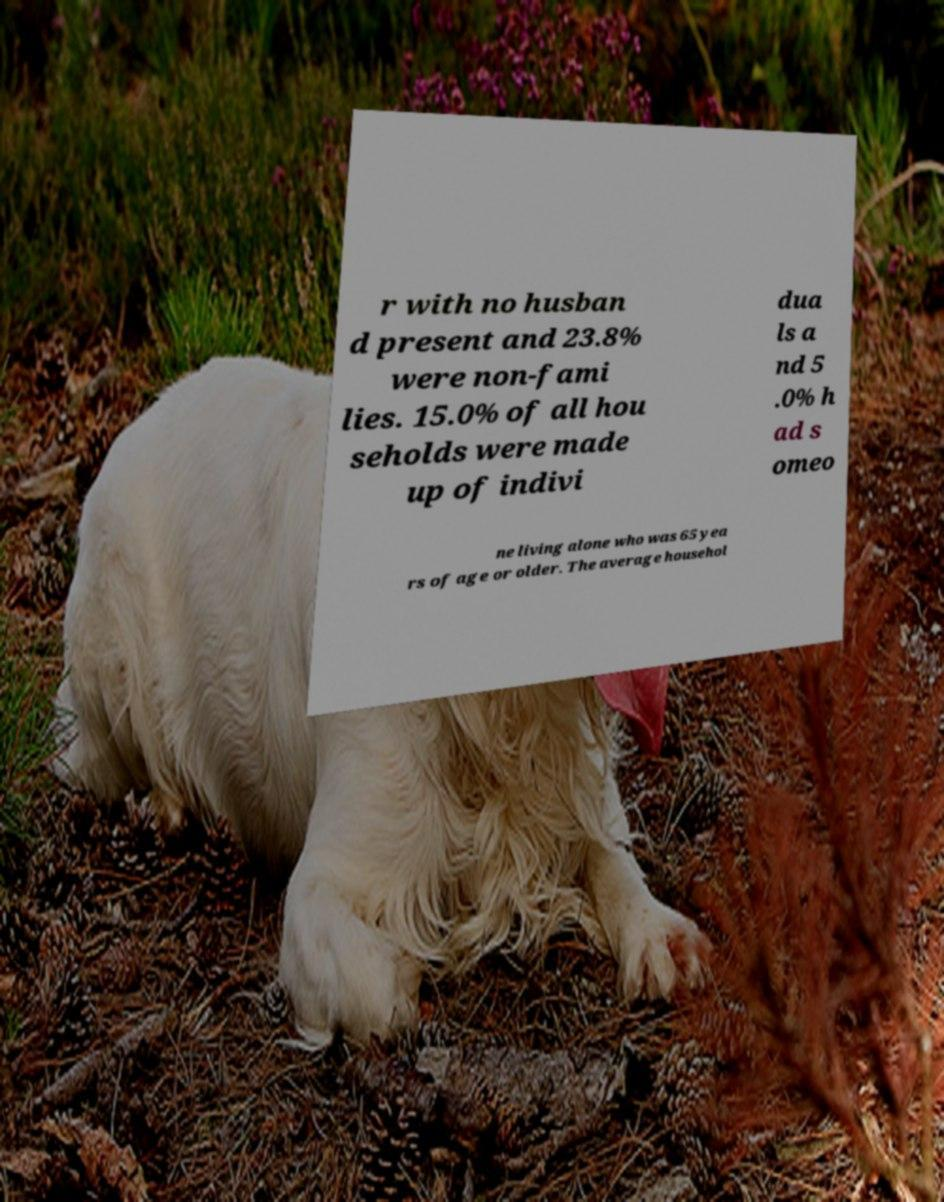For documentation purposes, I need the text within this image transcribed. Could you provide that? r with no husban d present and 23.8% were non-fami lies. 15.0% of all hou seholds were made up of indivi dua ls a nd 5 .0% h ad s omeo ne living alone who was 65 yea rs of age or older. The average househol 